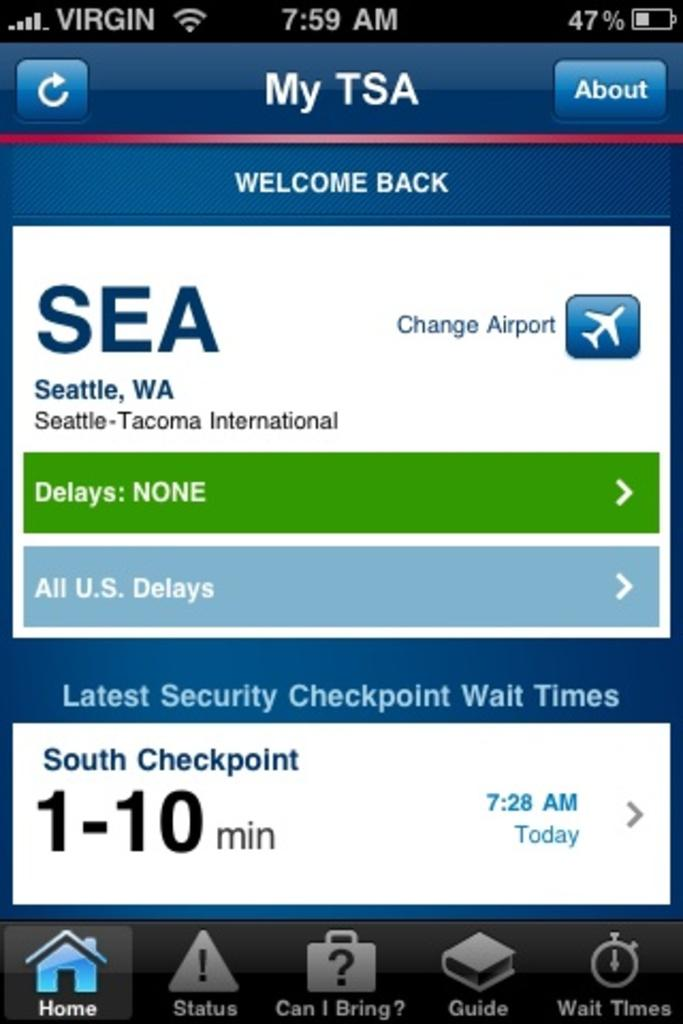<image>
Create a compact narrative representing the image presented. screenshot from iphone about airplane ticket and times boarding 